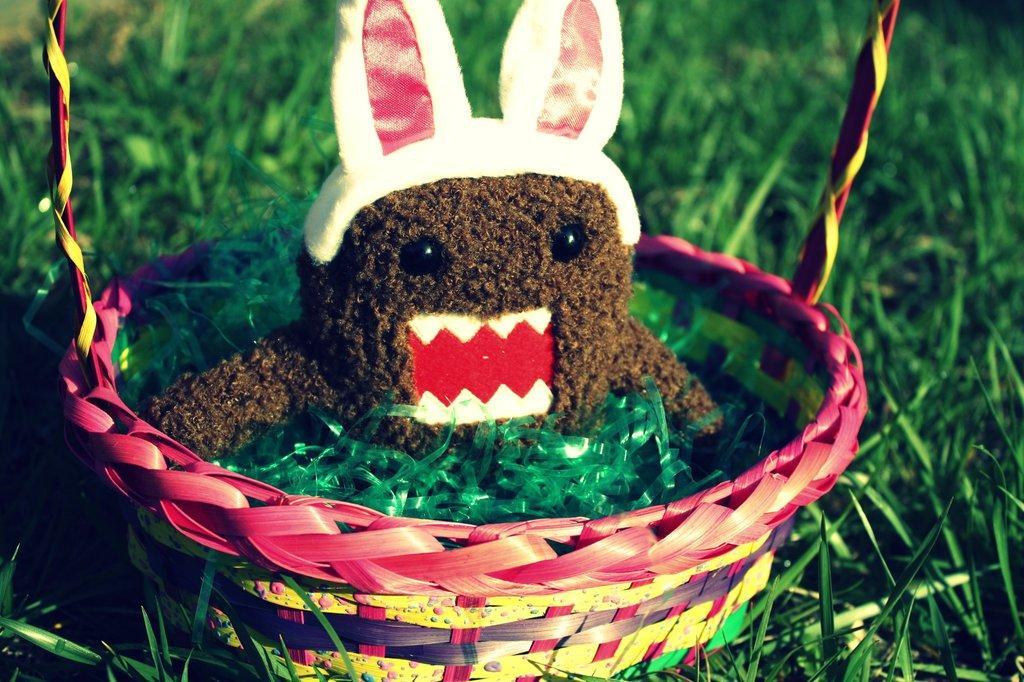What is located in the foreground of the image? There is a basket in the foreground of the image. What is inside the basket? There is a doll in the basket. Can you describe the doll's appearance? The doll has green stripes. What can be seen in the background of the image? There is grass visible in the background of the image. What type of idea can be seen being hammered on the gate in the image? There is no gate, hammer, or idea present in the image. 